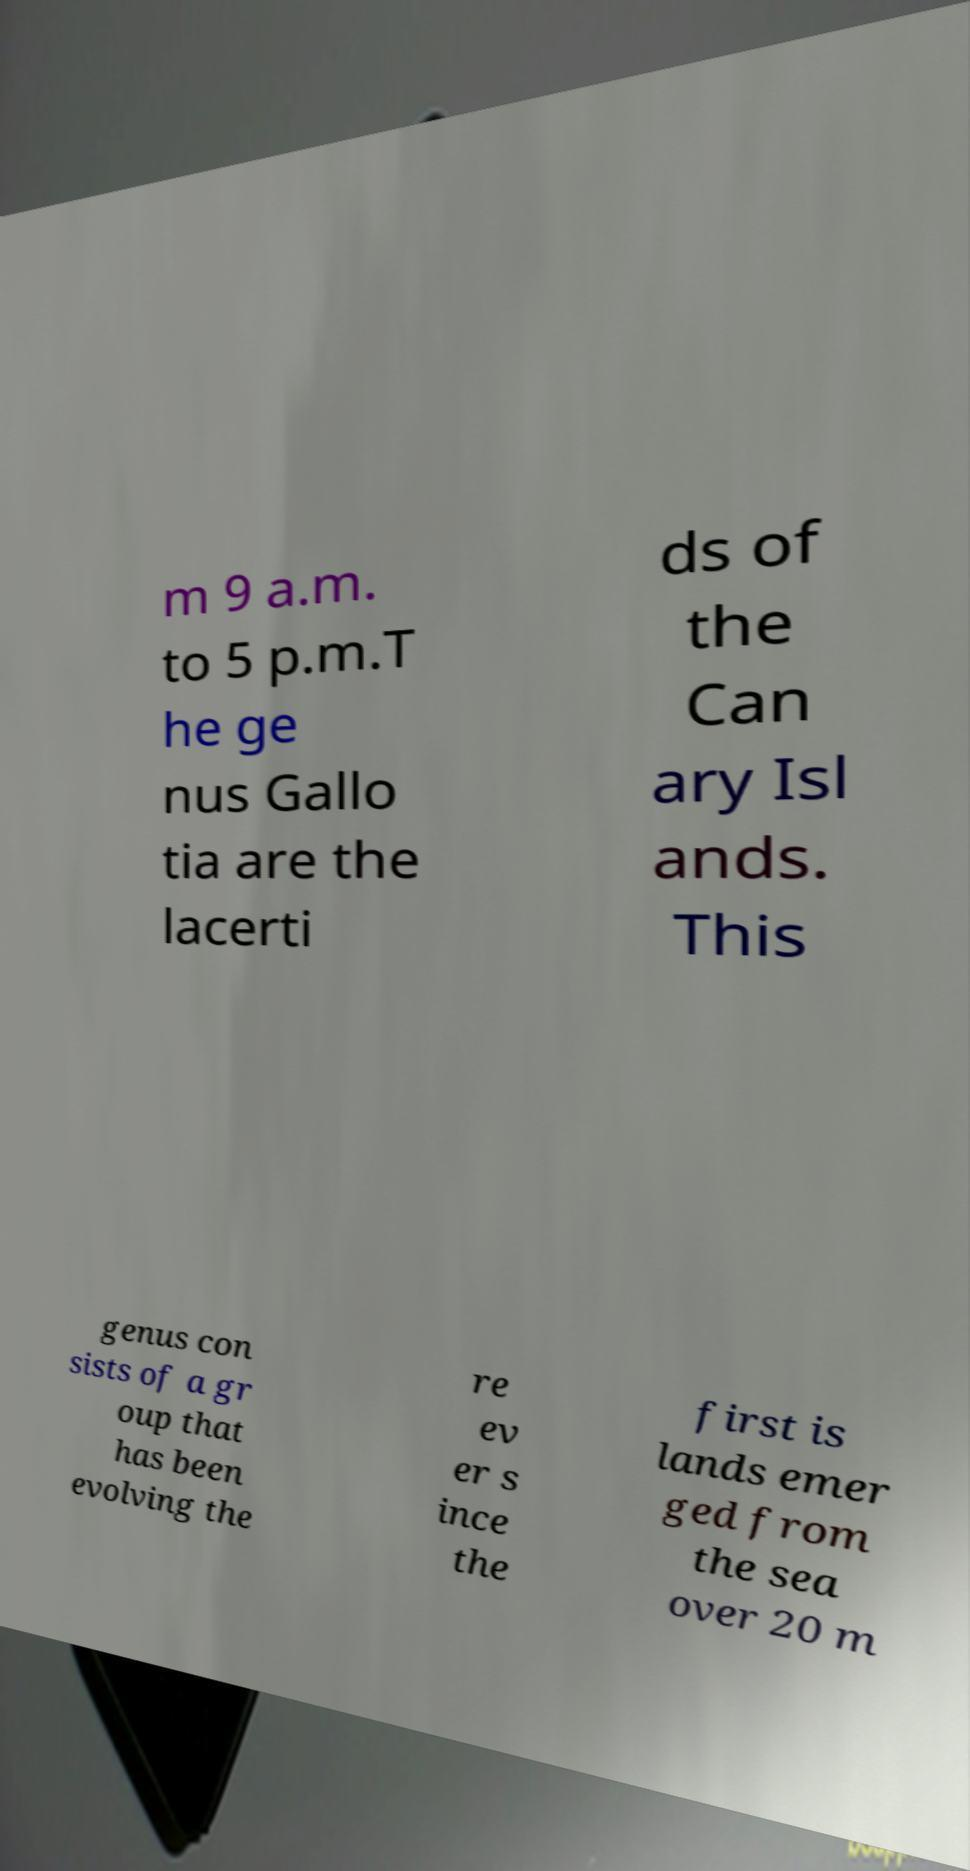For documentation purposes, I need the text within this image transcribed. Could you provide that? m 9 a.m. to 5 p.m.T he ge nus Gallo tia are the lacerti ds of the Can ary Isl ands. This genus con sists of a gr oup that has been evolving the re ev er s ince the first is lands emer ged from the sea over 20 m 